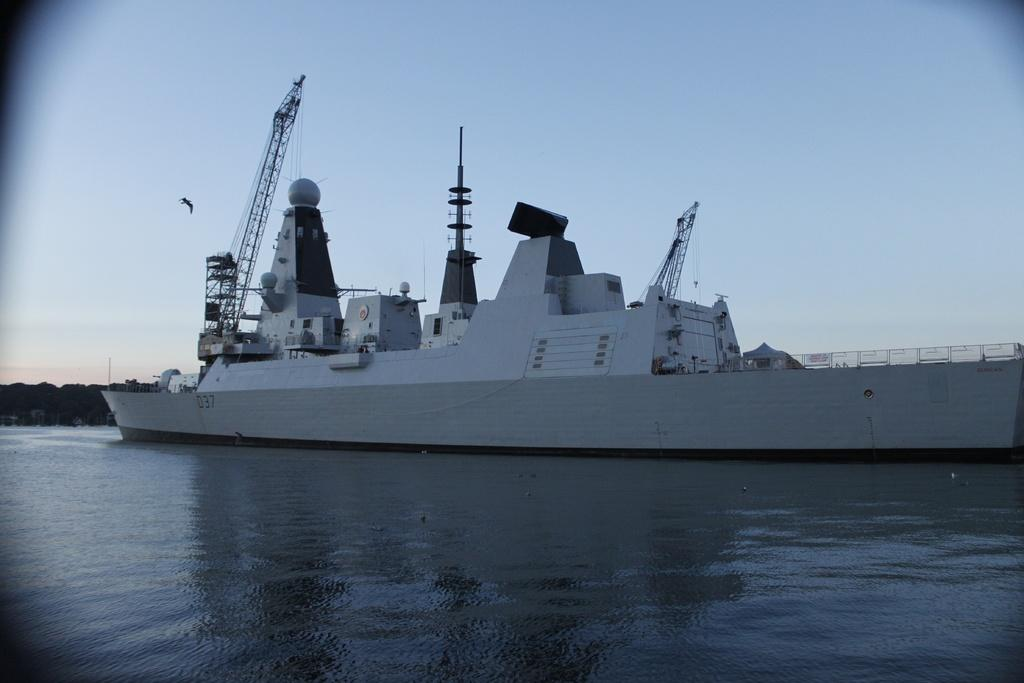What is the main subject in the center of the image? There is a ship in the center of the image. Where is the ship located? The ship is on the water. What can be seen in the background of the image? There are buildings, trees, a bird, and the sky visible in the background of the image. What is present at the bottom of the image? There is water at the bottom of the image. What type of collar can be seen on the bird in the image? There is no bird wearing a collar in the image; the bird is visible without any collar. 